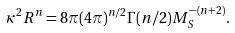<formula> <loc_0><loc_0><loc_500><loc_500>\kappa ^ { 2 } R ^ { n } = 8 \pi ( 4 \pi ) ^ { n / 2 } \Gamma ( n / 2 ) M _ { S } ^ { - ( n + 2 ) } .</formula> 